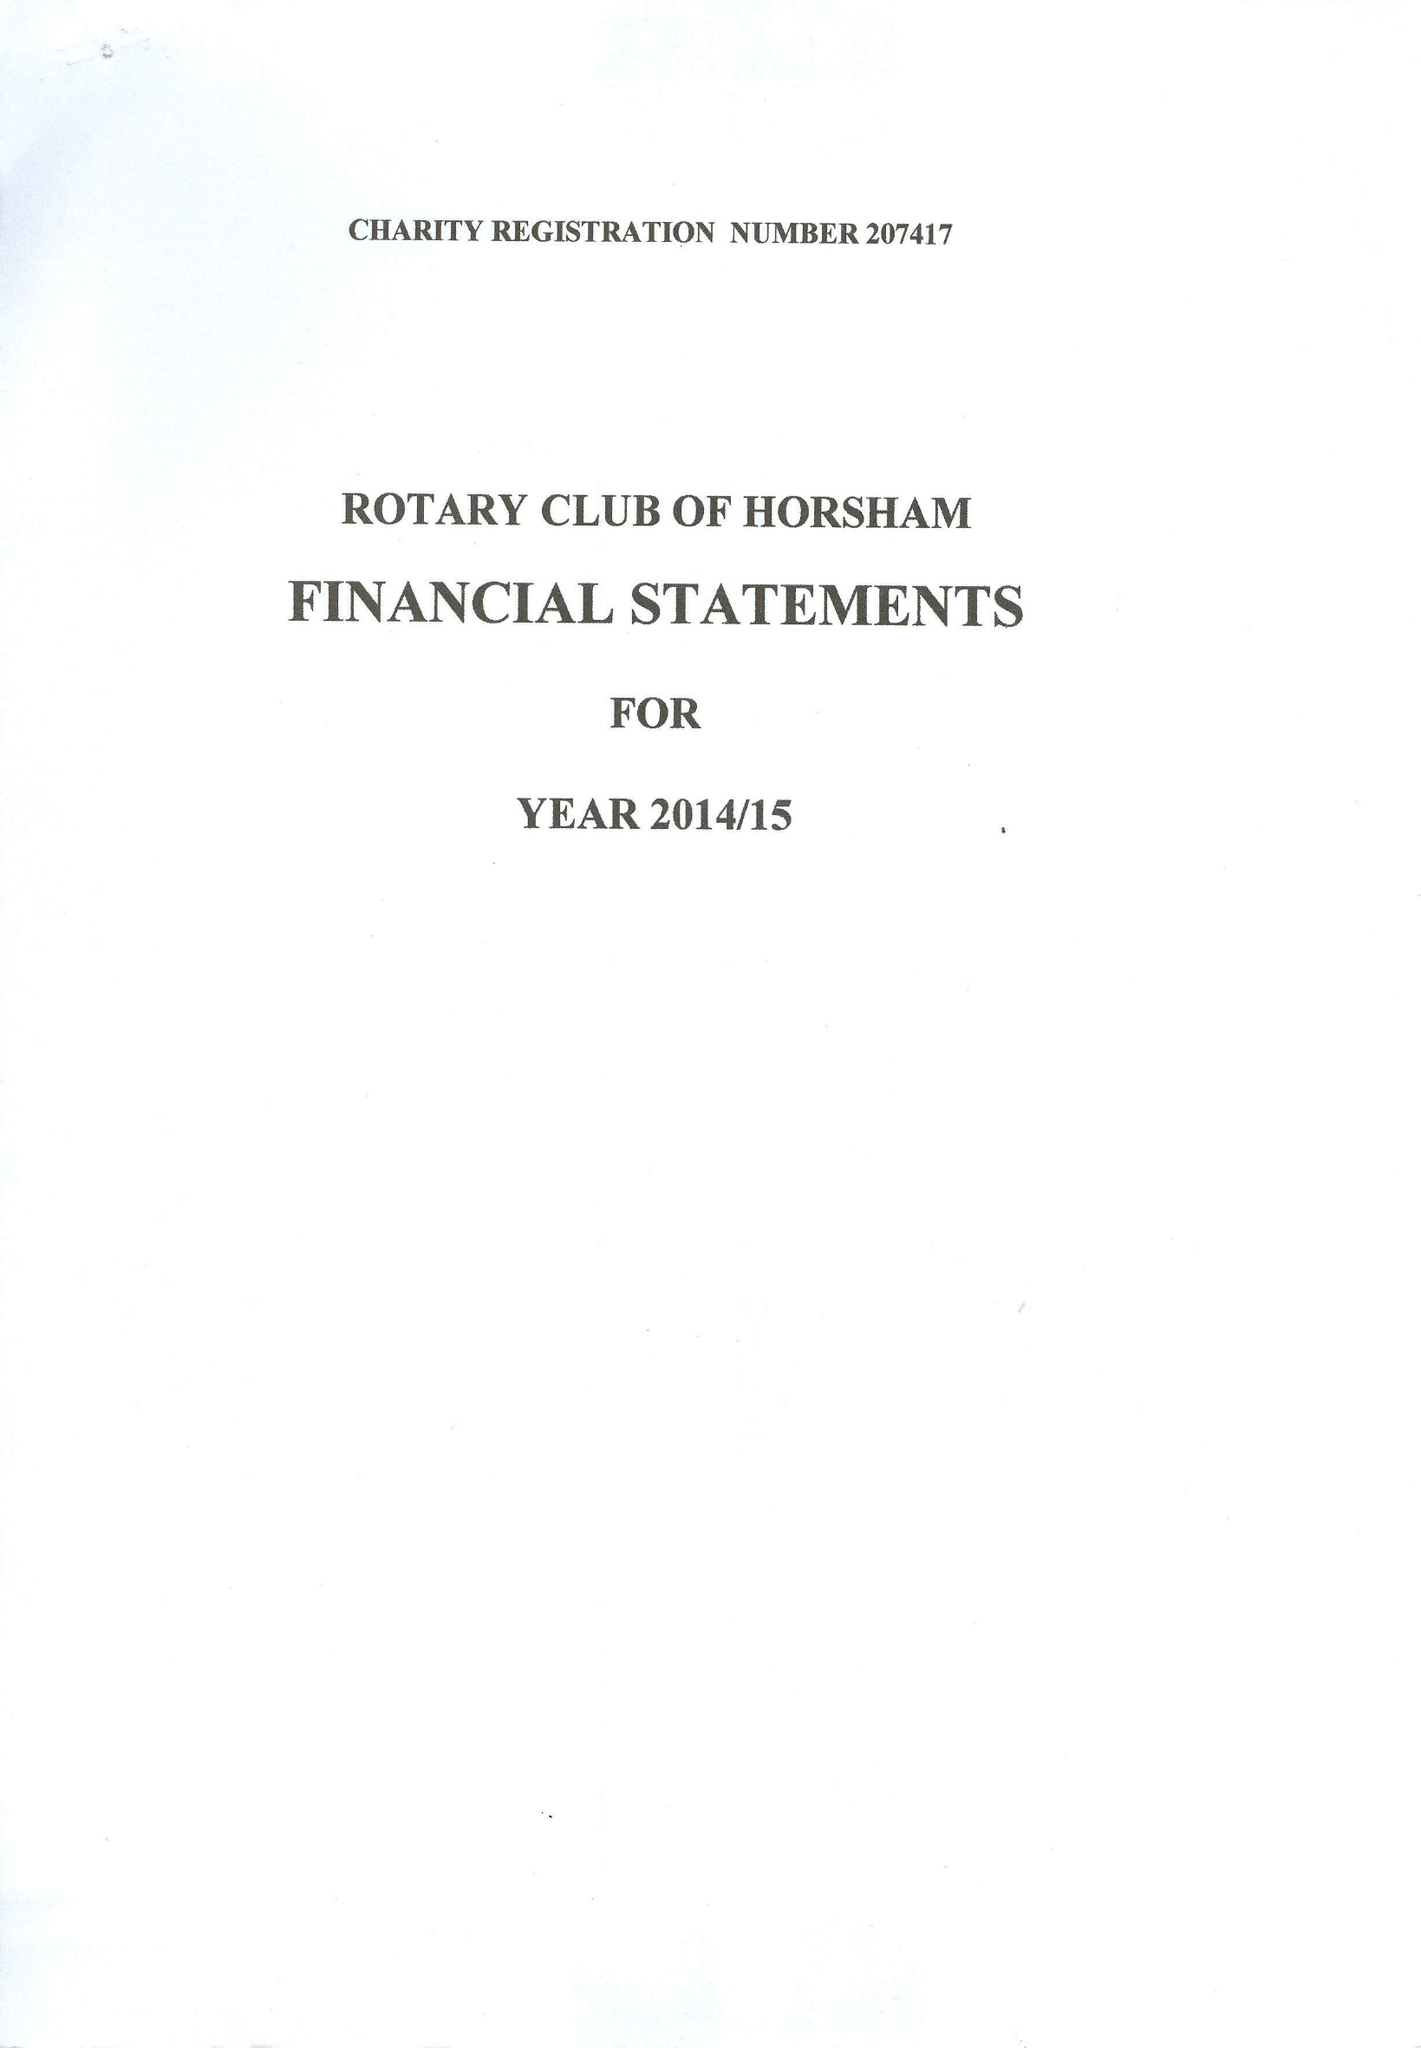What is the value for the income_annually_in_british_pounds?
Answer the question using a single word or phrase. 31130.00 